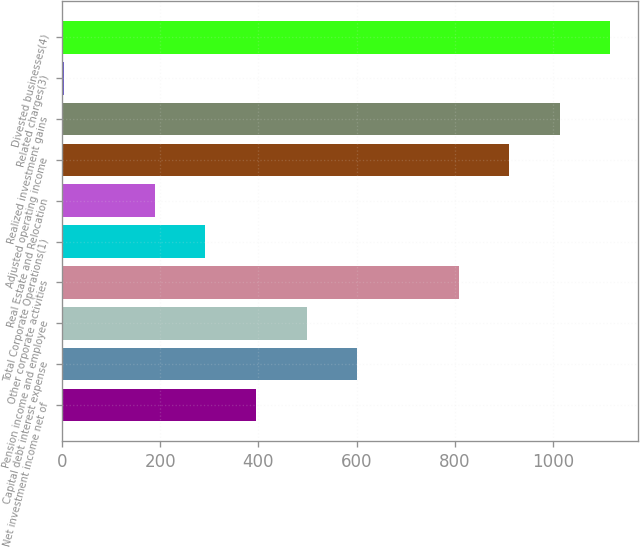Convert chart to OTSL. <chart><loc_0><loc_0><loc_500><loc_500><bar_chart><fcel>Net investment income net of<fcel>Capital debt interest expense<fcel>Pension income and employee<fcel>Other corporate activities<fcel>Total Corporate Operations(1)<fcel>Real Estate and Relocation<fcel>Adjusted operating income<fcel>Realized investment gains<fcel>Related charges(3)<fcel>Divested businesses(4)<nl><fcel>395.2<fcel>601.4<fcel>498.3<fcel>807.6<fcel>292.1<fcel>189<fcel>910.7<fcel>1013.8<fcel>4<fcel>1116.9<nl></chart> 